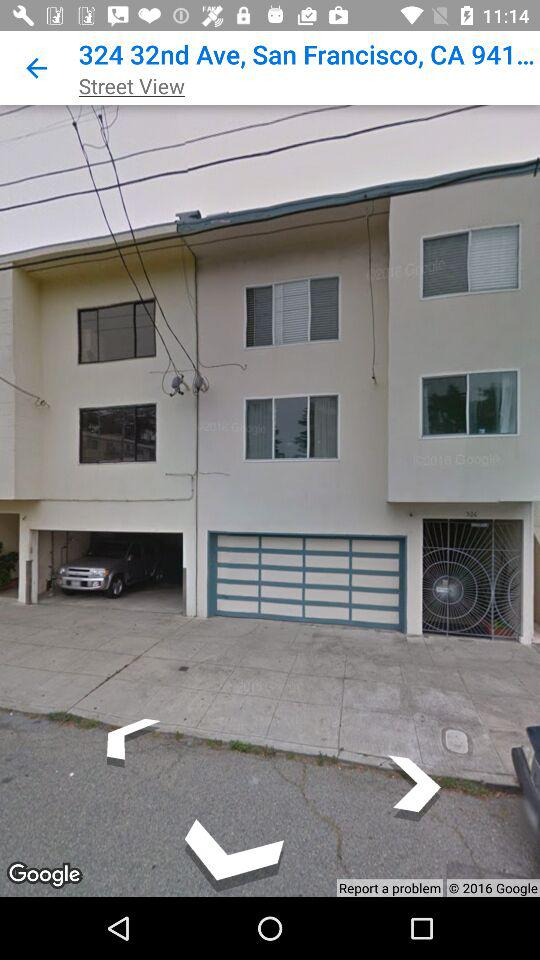What is the given location? The given location is "324 32nd Ave, San Francisco, CA 941...". 